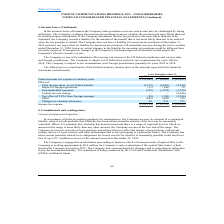From Cogent Communications Group's financial document, What are the respective federal income tax expense at statutory rates in 2017 and 2018? The document shows two values: 10,892 and 8,690 (in thousands). From the document: "come tax expense at statutory rates $ (11,061) $ (8,690) $ (10,892) Effect of: State income taxes, net of federal benefit (2,973) (2,665) (2,244) Impa..." Also, What are the respective federal income tax expense at statutory rates in 2018 and 2019? The document shows two values: 8,690 and 11,061 (in thousands). From the document: "Federal income tax expense at statutory rates $ (11,061) $ (8,690) $ (10,892) Effect of: State income taxes, net of federal benefit (2,973) (2,665) (2..." Also, What are the respective state income taxes, net of federal benefit in 2017 and 2018? The document shows two values: 2,244 and 2,665 (in thousands). From the document: "ate income taxes, net of federal benefit (2,973) (2,665) (2,244) Impact of foreign operations (11) (146) 74 Non-deductible expenses (592) (1,274) (1,3..." Also, can you calculate: What is the average federal income tax expense at statutory rates in 2017 and 2018? To answer this question, I need to perform calculations using the financial data. The calculation is: (10,892 + 8,690)/2 , which equals 9791 (in thousands). This is based on the information: "come tax expense at statutory rates $ (11,061) $ (8,690) $ (10,892) Effect of: State income taxes, net of federal benefit (2,973) (2,665) (2,244) Impact of xpense at statutory rates $ (11,061) $ (8,69..." The key data points involved are: 10,892, 8,690. Also, can you calculate: What is the average federal income tax expense at statutory rates in 2018 and 2019? To answer this question, I need to perform calculations using the financial data. The calculation is: (8,690 + 11,061)/2 , which equals 9875.5 (in thousands). This is based on the information: "Federal income tax expense at statutory rates $ (11,061) $ (8,690) $ (10,892) Effect of: State income taxes, net of federal benefit (2,973) (2,665) (2,244) come tax expense at statutory rates $ (11,06..." The key data points involved are: 11,061, 8,690. Also, can you calculate: What is the average state income taxes, net of federal benefit in 2017 and 2018? To answer this question, I need to perform calculations using the financial data. The calculation is: (2,244 + 2,665)/2 , which equals 2454.5 (in thousands). This is based on the information: "ate income taxes, net of federal benefit (2,973) (2,665) (2,244) Impact of foreign operations (11) (146) 74 Non-deductible expenses (592) (1,274) (1,350) F me taxes, net of federal benefit (2,973) (2,..." The key data points involved are: 2,244, 2,665. 